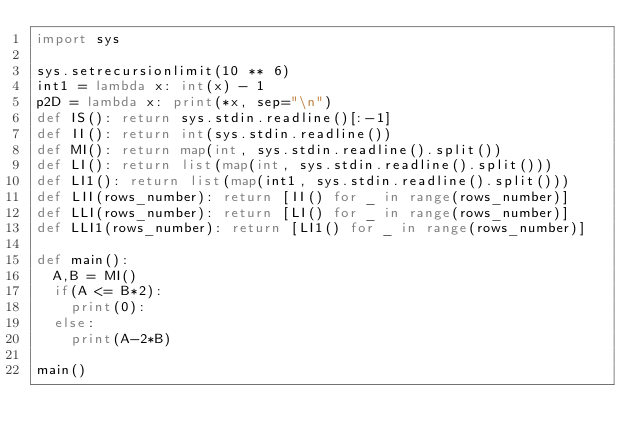<code> <loc_0><loc_0><loc_500><loc_500><_Python_>import sys

sys.setrecursionlimit(10 ** 6)
int1 = lambda x: int(x) - 1
p2D = lambda x: print(*x, sep="\n")
def IS(): return sys.stdin.readline()[:-1]
def II(): return int(sys.stdin.readline())
def MI(): return map(int, sys.stdin.readline().split())
def LI(): return list(map(int, sys.stdin.readline().split()))
def LI1(): return list(map(int1, sys.stdin.readline().split()))
def LII(rows_number): return [II() for _ in range(rows_number)]
def LLI(rows_number): return [LI() for _ in range(rows_number)]
def LLI1(rows_number): return [LI1() for _ in range(rows_number)]

def main():
	A,B = MI()
	if(A <= B*2):
		print(0):
	else:
		print(A-2*B)

main()</code> 